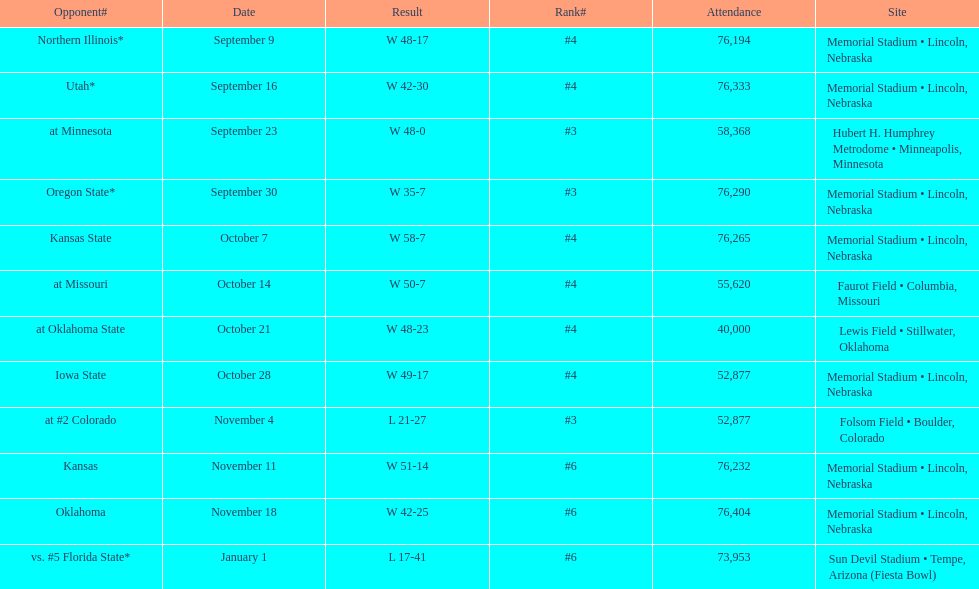Which month appears the least frequently on this chart? January. 